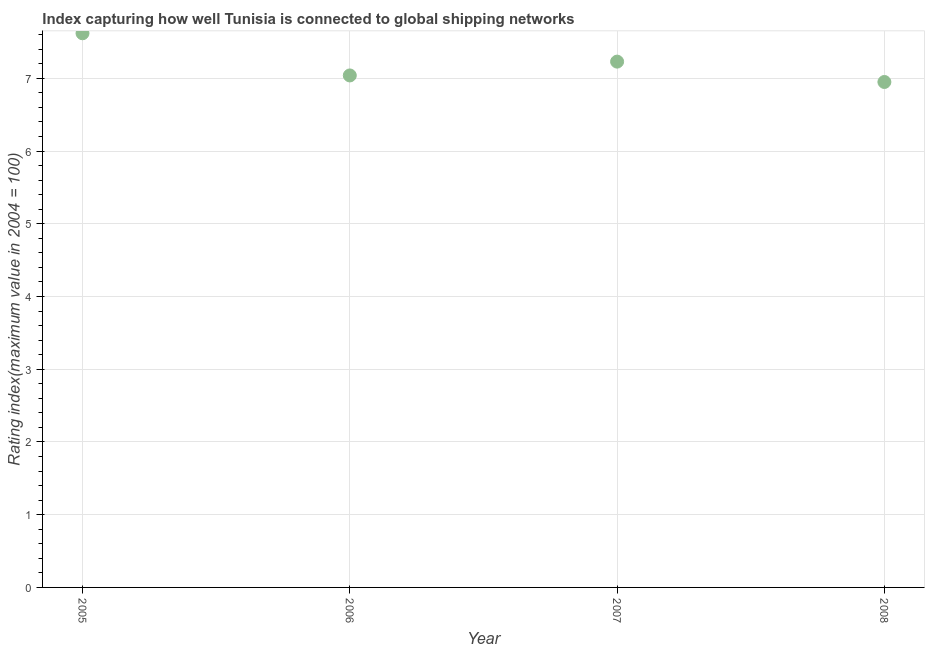What is the liner shipping connectivity index in 2006?
Ensure brevity in your answer.  7.04. Across all years, what is the maximum liner shipping connectivity index?
Keep it short and to the point. 7.62. Across all years, what is the minimum liner shipping connectivity index?
Keep it short and to the point. 6.95. What is the sum of the liner shipping connectivity index?
Make the answer very short. 28.84. What is the difference between the liner shipping connectivity index in 2005 and 2008?
Your answer should be compact. 0.67. What is the average liner shipping connectivity index per year?
Offer a terse response. 7.21. What is the median liner shipping connectivity index?
Your answer should be compact. 7.13. What is the ratio of the liner shipping connectivity index in 2006 to that in 2008?
Ensure brevity in your answer.  1.01. Is the liner shipping connectivity index in 2005 less than that in 2008?
Your answer should be very brief. No. What is the difference between the highest and the second highest liner shipping connectivity index?
Offer a terse response. 0.39. What is the difference between the highest and the lowest liner shipping connectivity index?
Your answer should be compact. 0.67. Does the liner shipping connectivity index monotonically increase over the years?
Make the answer very short. No. How many dotlines are there?
Keep it short and to the point. 1. How many years are there in the graph?
Make the answer very short. 4. Are the values on the major ticks of Y-axis written in scientific E-notation?
Your response must be concise. No. Does the graph contain any zero values?
Your response must be concise. No. What is the title of the graph?
Your answer should be very brief. Index capturing how well Tunisia is connected to global shipping networks. What is the label or title of the X-axis?
Keep it short and to the point. Year. What is the label or title of the Y-axis?
Ensure brevity in your answer.  Rating index(maximum value in 2004 = 100). What is the Rating index(maximum value in 2004 = 100) in 2005?
Offer a terse response. 7.62. What is the Rating index(maximum value in 2004 = 100) in 2006?
Make the answer very short. 7.04. What is the Rating index(maximum value in 2004 = 100) in 2007?
Provide a short and direct response. 7.23. What is the Rating index(maximum value in 2004 = 100) in 2008?
Make the answer very short. 6.95. What is the difference between the Rating index(maximum value in 2004 = 100) in 2005 and 2006?
Keep it short and to the point. 0.58. What is the difference between the Rating index(maximum value in 2004 = 100) in 2005 and 2007?
Make the answer very short. 0.39. What is the difference between the Rating index(maximum value in 2004 = 100) in 2005 and 2008?
Make the answer very short. 0.67. What is the difference between the Rating index(maximum value in 2004 = 100) in 2006 and 2007?
Give a very brief answer. -0.19. What is the difference between the Rating index(maximum value in 2004 = 100) in 2006 and 2008?
Offer a very short reply. 0.09. What is the difference between the Rating index(maximum value in 2004 = 100) in 2007 and 2008?
Offer a very short reply. 0.28. What is the ratio of the Rating index(maximum value in 2004 = 100) in 2005 to that in 2006?
Your response must be concise. 1.08. What is the ratio of the Rating index(maximum value in 2004 = 100) in 2005 to that in 2007?
Provide a succinct answer. 1.05. What is the ratio of the Rating index(maximum value in 2004 = 100) in 2005 to that in 2008?
Give a very brief answer. 1.1. What is the ratio of the Rating index(maximum value in 2004 = 100) in 2006 to that in 2008?
Your answer should be compact. 1.01. 